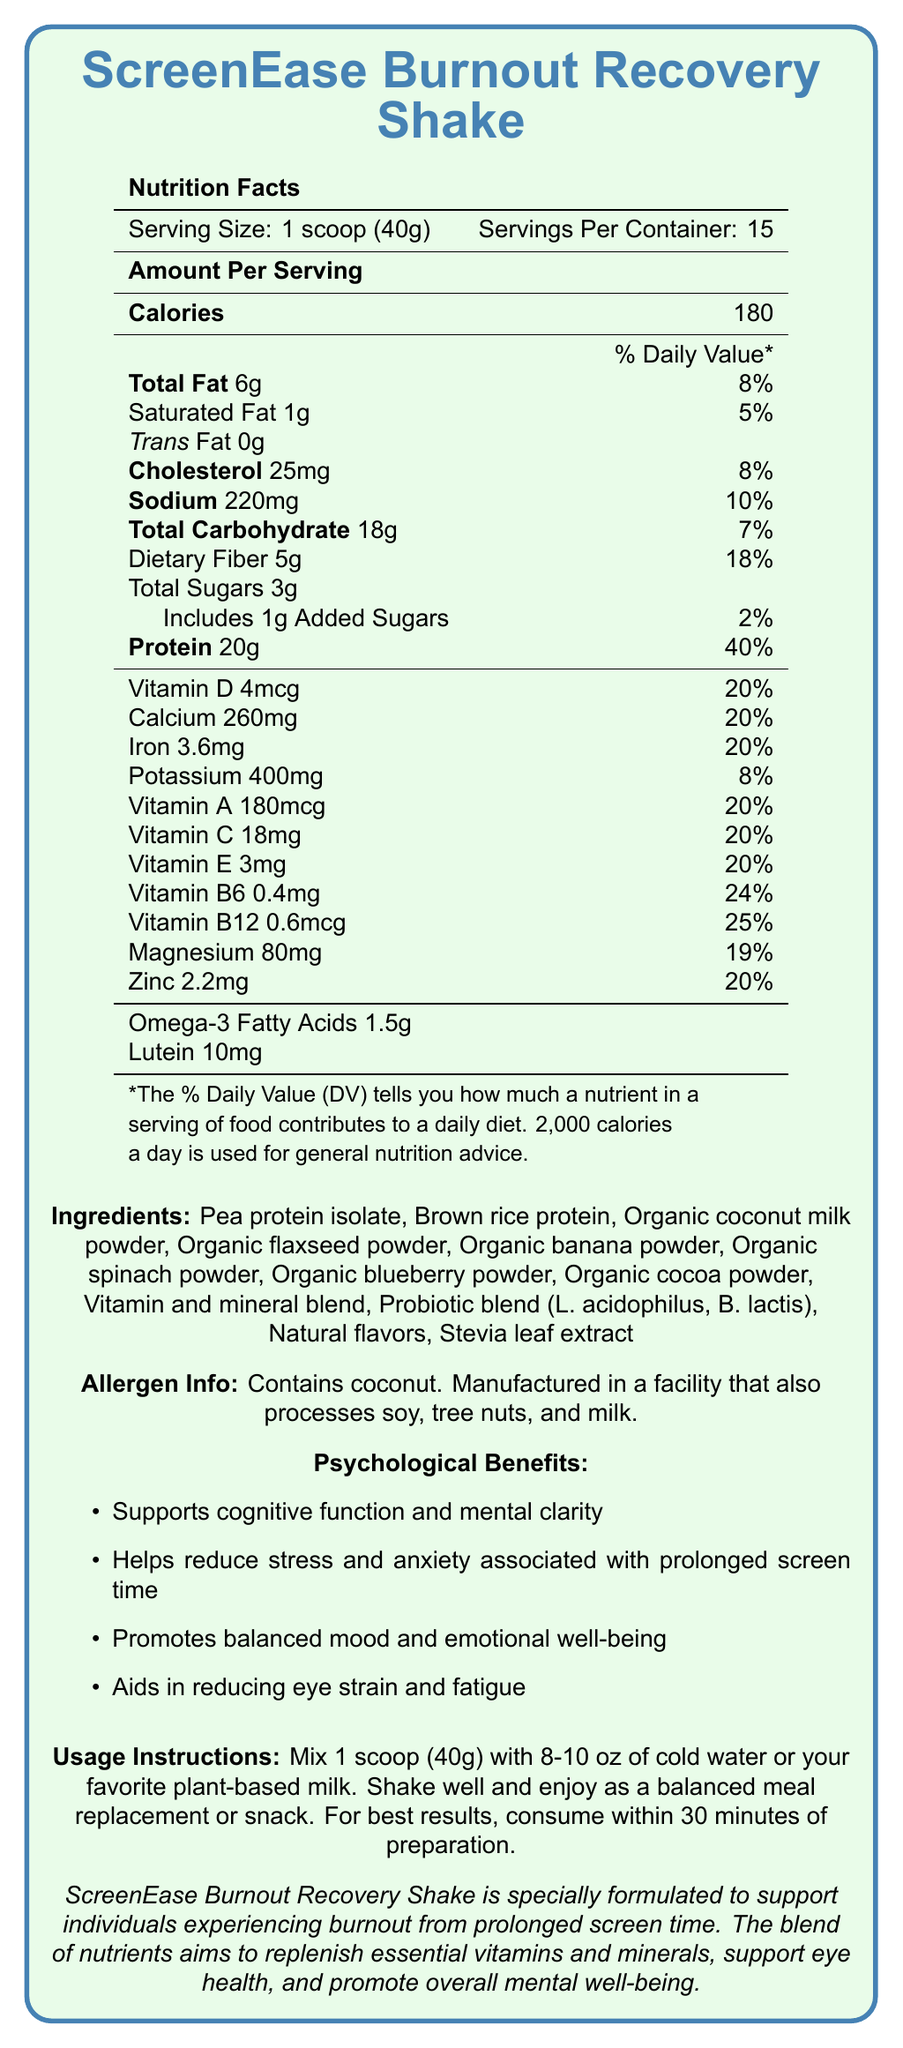What is the serving size of ScreenEase Burnout Recovery Shake? The serving size is indicated in the Nutrition Facts section: "Serving Size: 1 scoop (40g)".
Answer: 1 scoop (40g) How many calories are in one serving of the ScreenEase Burnout Recovery Shake? The document states "Calories 180" under the Amount Per Serving section.
Answer: 180 Which vitamins contribute 20% of the Daily Value in each serving? These vitamins are listed with "20%" Daily Value according to the Nutrition Facts section in the document.
Answer: Vitamin D, Calcium, Iron, Vitamin A, Vitamin C, Vitamin E, Zinc How much protein does one serving contain? The Nutrition Facts section specifies "Protein 20g" under Amount Per Serving.
Answer: 20g What are the possible allergens present in the ScreenEase Burnout Recovery Shake? The allergen information is stated under the Allergen Info section.
Answer: Contains coconut. Manufactured in a facility that also processes soy, tree nuts, and milk. How much dietary fiber is in one serving? The document specifies "Dietary Fiber 5g" under the Total Carbohydrate section in the Nutrition Facts.
Answer: 5g Which ingredient in ScreenEase Burnout Recovery Shake serves as a protein source? These two ingredients are listed first under the Ingredients section.
Answer: Pea protein isolate, Brown rice protein Based on the document, which of the following is NOT a psychological benefit of the ScreenEase Burnout Recovery Shake? A. Supports cognitive function B. Increases physical strength C. Helps reduce stress The Psychological Benefits section mentions cognitive function and stress reduction but nothing about increasing physical strength.
Answer: B How many servings are there per container? A. 10 B. 12 C. 15 D. 20 The document states "Servings Per Container: 15" in the Nutrition Facts.
Answer: C Is this product suitable for someone allergic to milk? The document notes the product is manufactured in a facility that processes milk, as stated in the Allergen Info section.
Answer: No Summarize the main nutritional benefits of the ScreenEase Burnout Recovery Shake. The summary details the key nutritional and psychological benefits, emphasizing both the nutrient content and specific psychological and physical well-being advantages.
Answer: The shake provides a substantial amount of protein (20g), supports cognitive and mental health with a variety of essential vitamins and minerals, and assists in reducing stress and eye strain caused by prolonged screen time. What is the main purpose of the ScreenEase Burnout Recovery Shake? The additional information and the psychological benefits sections explain the primary purpose of the product.
Answer: Helps individuals experiencing burnout from prolonged screen time by replenishing essential vitamins and minerals, supporting eye health, and promoting overall mental well-being. Which ingredient contributes Omega-3 fatty acids to the ScreenEase Burnout Recovery Shake? Omega-3 fatty acids are usually derived from flaxseed, which is one of the listed ingredients.
Answer: Organic flaxseed powder Can I find information on the specific amounts of probiotics in each serving? The document mentions a probiotic blend but does not provide specific amounts for each type of probiotic.
Answer: Not enough information How do you prepare the ScreenEase Burnout Recovery Shake? The usage instructions clearly outline these steps.
Answer: Mix 1 scoop (40g) with 8-10 oz of cold water or plant-based milk. Shake well and consume within 30 minutes of preparation. What percentage of the Daily Value for Vitamin B12 is provided by one serving? The Nutrition Facts section lists Vitamin B12 with a Daily Value of 25%.
Answer: 25% 